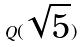Convert formula to latex. <formula><loc_0><loc_0><loc_500><loc_500>Q ( \sqrt { 5 } )</formula> 